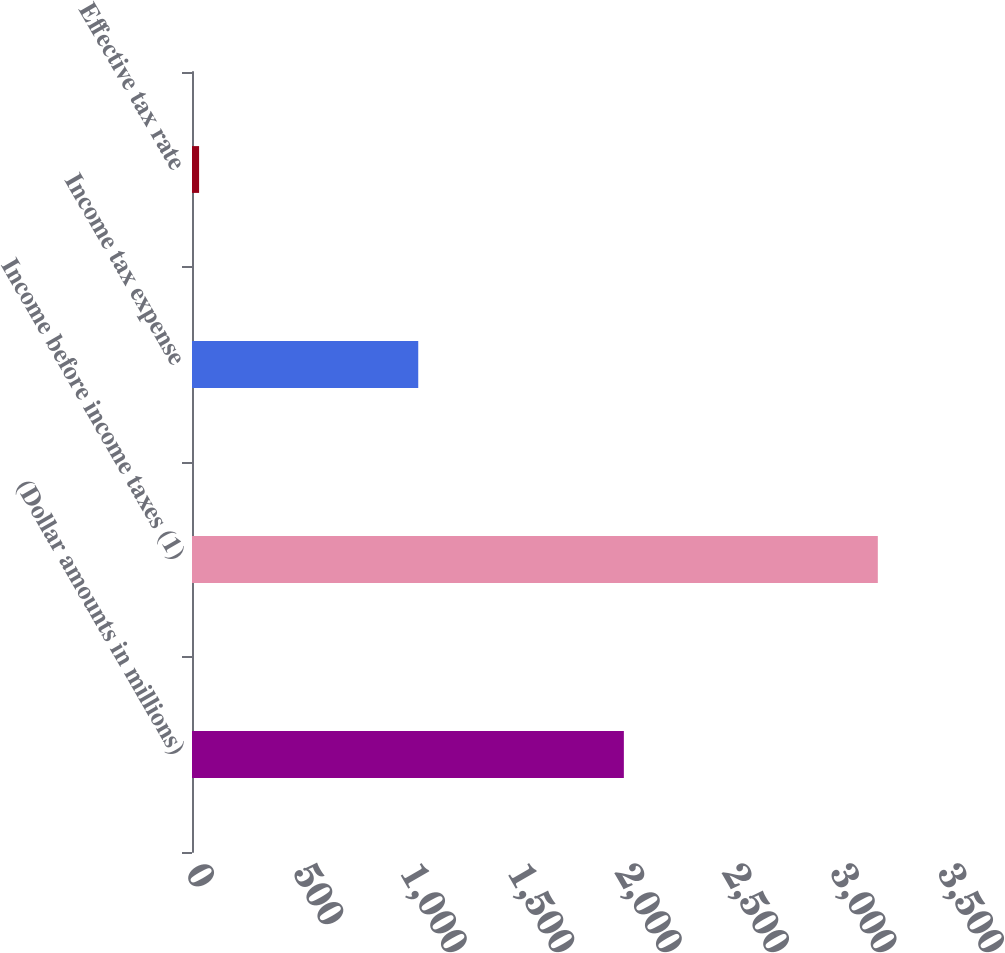<chart> <loc_0><loc_0><loc_500><loc_500><bar_chart><fcel>(Dollar amounts in millions)<fcel>Income before income taxes (1)<fcel>Income tax expense<fcel>Effective tax rate<nl><fcel>2010<fcel>3192<fcel>1053<fcel>33<nl></chart> 